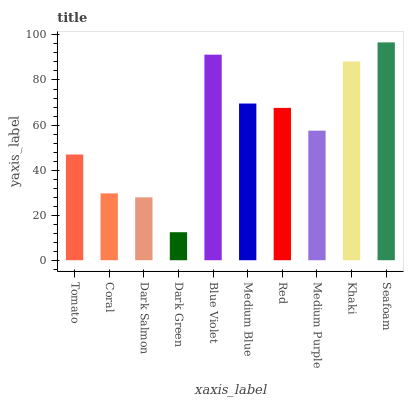Is Dark Green the minimum?
Answer yes or no. Yes. Is Seafoam the maximum?
Answer yes or no. Yes. Is Coral the minimum?
Answer yes or no. No. Is Coral the maximum?
Answer yes or no. No. Is Tomato greater than Coral?
Answer yes or no. Yes. Is Coral less than Tomato?
Answer yes or no. Yes. Is Coral greater than Tomato?
Answer yes or no. No. Is Tomato less than Coral?
Answer yes or no. No. Is Red the high median?
Answer yes or no. Yes. Is Medium Purple the low median?
Answer yes or no. Yes. Is Dark Salmon the high median?
Answer yes or no. No. Is Seafoam the low median?
Answer yes or no. No. 